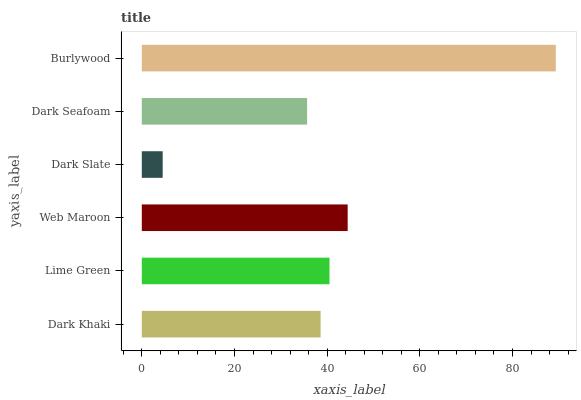Is Dark Slate the minimum?
Answer yes or no. Yes. Is Burlywood the maximum?
Answer yes or no. Yes. Is Lime Green the minimum?
Answer yes or no. No. Is Lime Green the maximum?
Answer yes or no. No. Is Lime Green greater than Dark Khaki?
Answer yes or no. Yes. Is Dark Khaki less than Lime Green?
Answer yes or no. Yes. Is Dark Khaki greater than Lime Green?
Answer yes or no. No. Is Lime Green less than Dark Khaki?
Answer yes or no. No. Is Lime Green the high median?
Answer yes or no. Yes. Is Dark Khaki the low median?
Answer yes or no. Yes. Is Web Maroon the high median?
Answer yes or no. No. Is Dark Slate the low median?
Answer yes or no. No. 